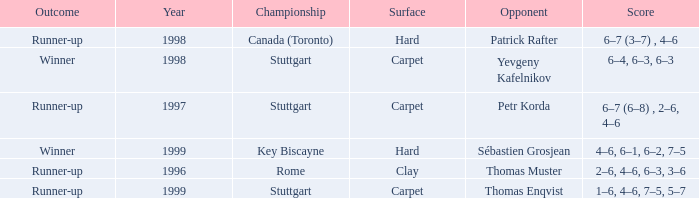Would you be able to parse every entry in this table? {'header': ['Outcome', 'Year', 'Championship', 'Surface', 'Opponent', 'Score'], 'rows': [['Runner-up', '1998', 'Canada (Toronto)', 'Hard', 'Patrick Rafter', '6–7 (3–7) , 4–6'], ['Winner', '1998', 'Stuttgart', 'Carpet', 'Yevgeny Kafelnikov', '6–4, 6–3, 6–3'], ['Runner-up', '1997', 'Stuttgart', 'Carpet', 'Petr Korda', '6–7 (6–8) , 2–6, 4–6'], ['Winner', '1999', 'Key Biscayne', 'Hard', 'Sébastien Grosjean', '4–6, 6–1, 6–2, 7–5'], ['Runner-up', '1996', 'Rome', 'Clay', 'Thomas Muster', '2–6, 4–6, 6–3, 3–6'], ['Runner-up', '1999', 'Stuttgart', 'Carpet', 'Thomas Enqvist', '1–6, 4–6, 7–5, 5–7']]} What championship after 1997 was the score 1–6, 4–6, 7–5, 5–7? Stuttgart. 